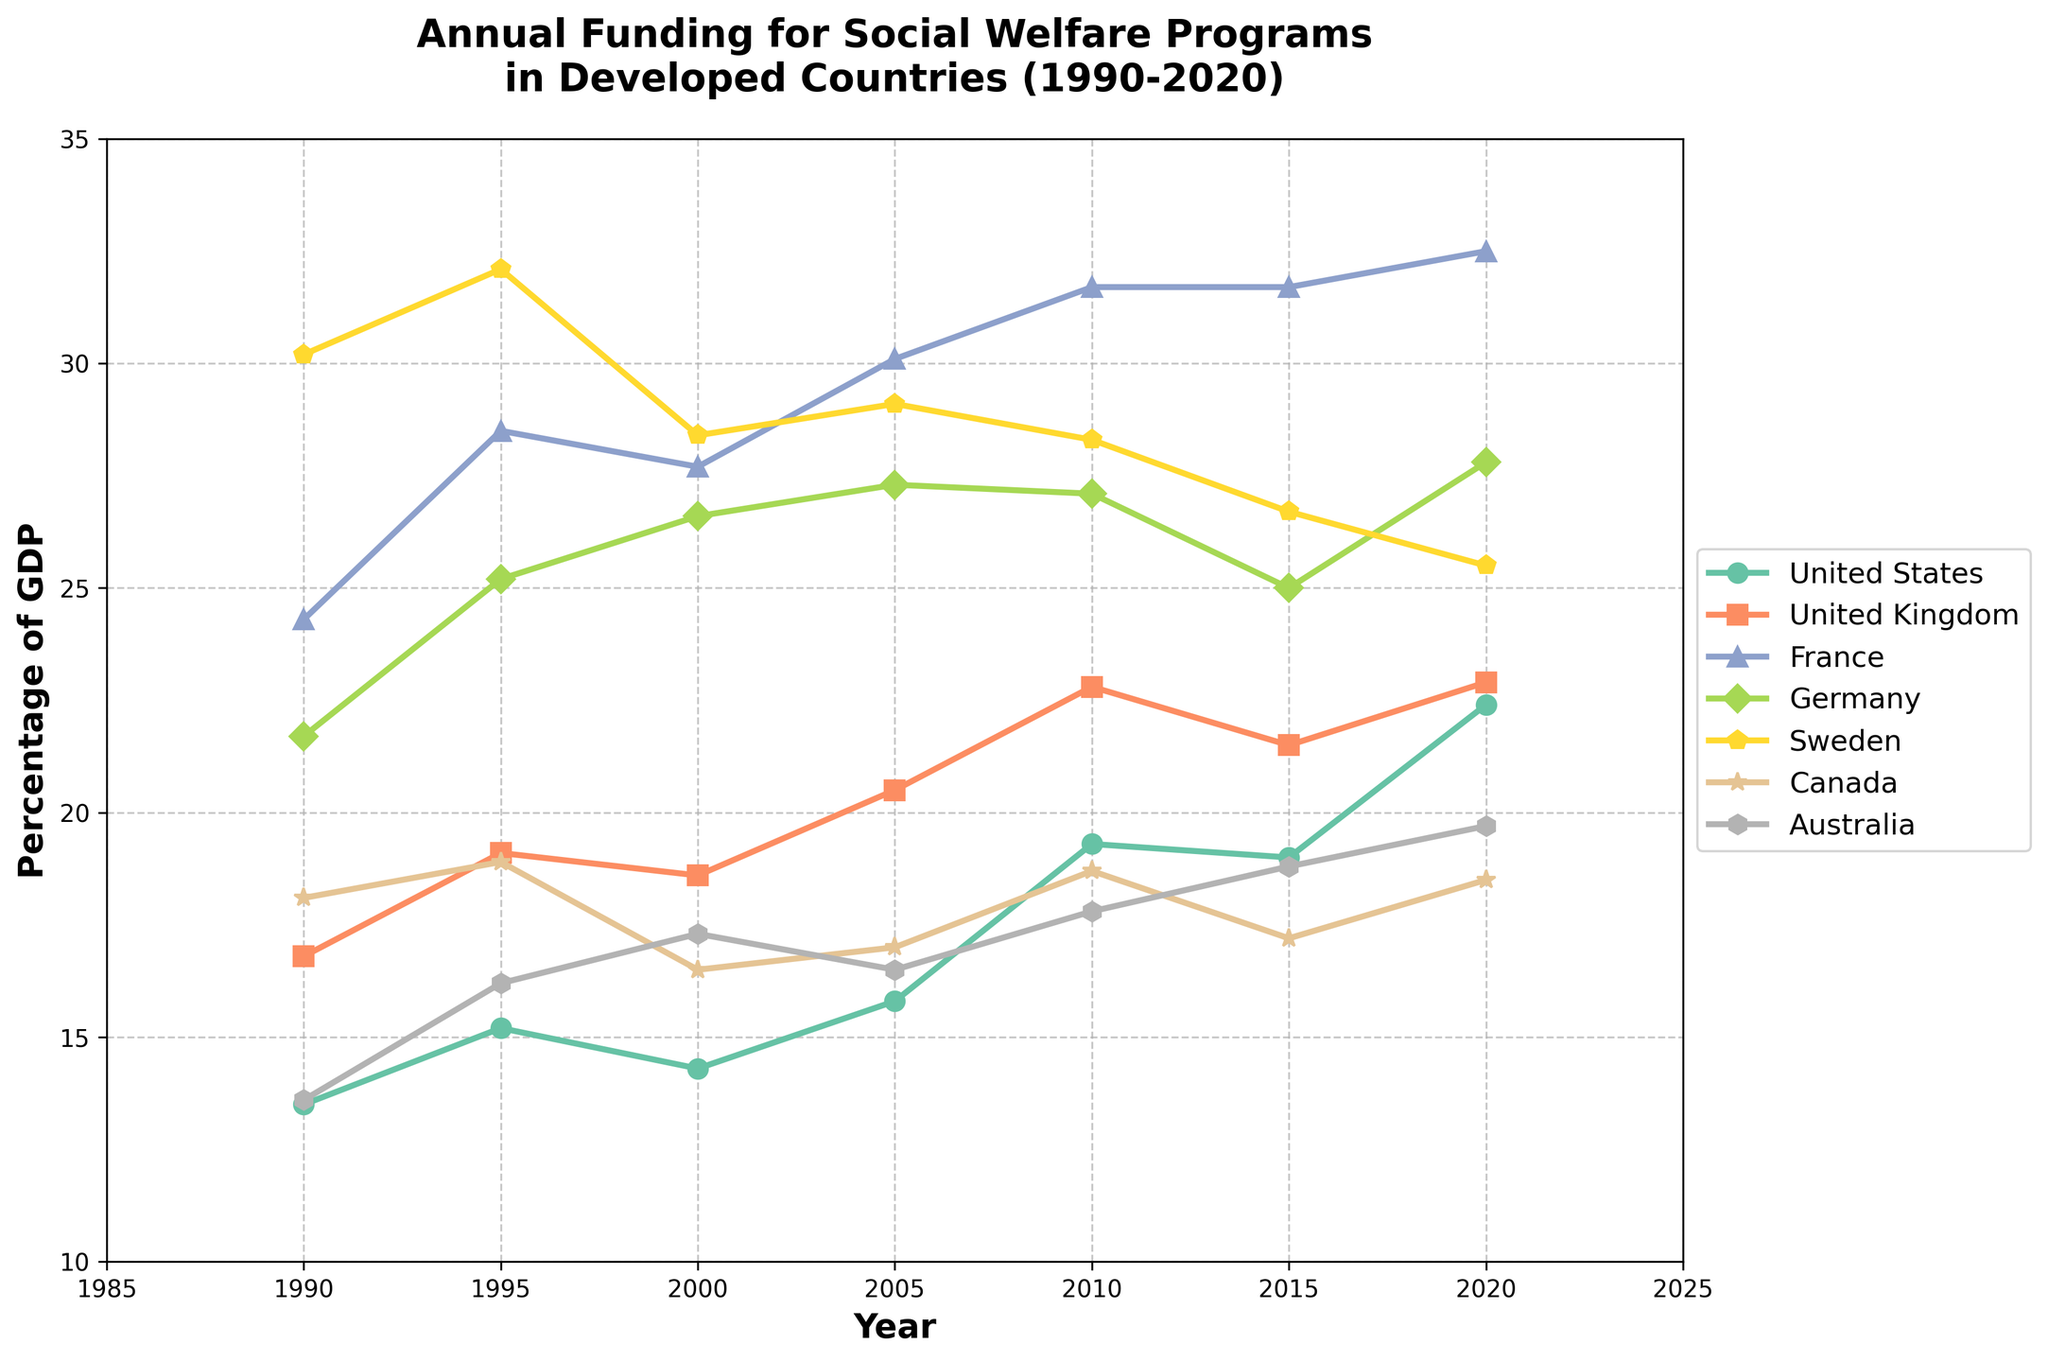Which country had the highest percentage of GDP allocated to social welfare programs in 2020? In 2020, Sweden had the highest allocation, represented by the top-most line in the chart.
Answer: Sweden What was the trend for social welfare funding in the United States from 1990 to 2020? The funding in the United States increased overall from 13.5% in 1990 to 22.4% in 2020, although there were some fluctuations, such as a slight decrease around 2000.
Answer: Increasing Among the seven countries, which had the most stable percentage of GDP allocated to social welfare between 1990 and 2020? By observing the lines, France's funding appears to be the most stable, consistently staying within a relatively tight range (24.3% to 32.5%).
Answer: France What was the average percentage of GDP allocated to social welfare programs by Sweden between 1990 and 2020? Sum the allocations for Sweden across the years (30.2 + 32.1 + 28.4 + 29.1 + 28.3 + 26.7 + 25.5 = 200.3), then divide by the number of years (7). 200.3/7 = 28.61.
Answer: 28.61% Which country showed the largest increase in social welfare funding as a percentage of GDP from 1990 to 2020? Calculate the difference between 2020 and 1990 for each country and compare: United States (22.4 - 13.5 = 8.9), United Kingdom (22.9 - 16.8 = 6.1), France (32.5 - 24.3 = 8.2), Germany (27.8 - 21.7 = 6.1), Sweden (25.5 - 30.2 = -4.7), Canada (18.5 - 18.1 = 0.4), Australia (19.7 - 13.6 = 6.1). The United States had the largest increase.
Answer: United States In which year did Germany allocate the highest percentage of its GDP to social welfare programs? Germany’s highest allocation was observed around 2005 and 2020, with a slight peak visible at 2020 (27.8%).
Answer: 2020 How does the social welfare funding trend for the United Kingdom compare to that of Canada between 1990 and 2020? The United Kingdom started higher and rose, peaking around 2010 before slightly decreasing by 2020. In contrast, Canada's allocation is relatively stable with minor fluctuations, overall staying stable from 1990 to 2020.
Answer: UK increased more, Canada stable 